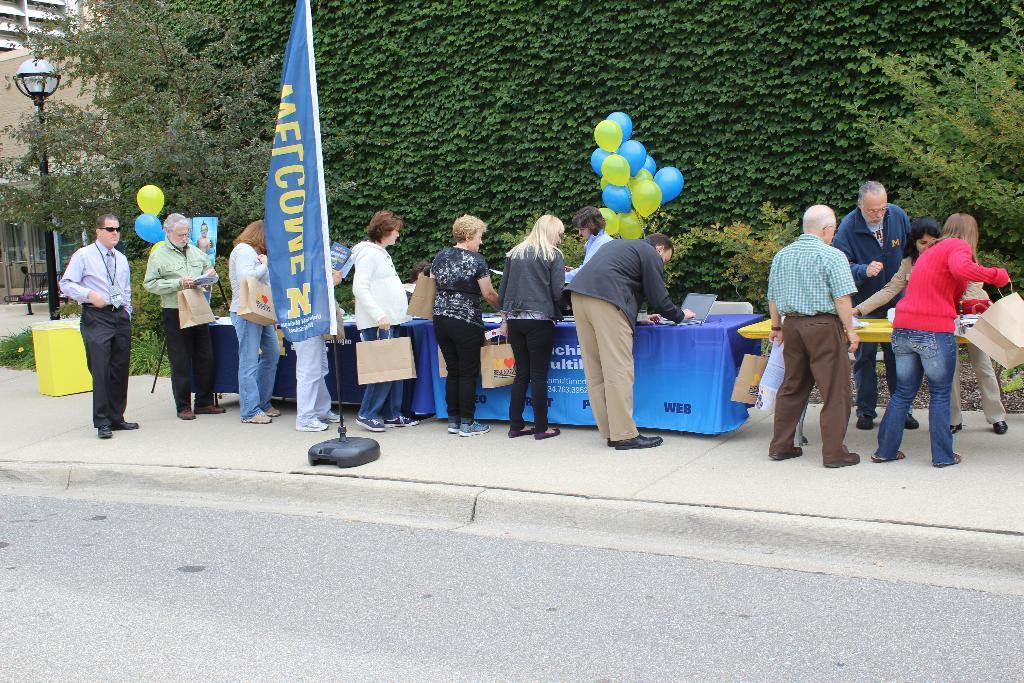How would you summarize this image in a sentence or two? This is an outside view. At the bottom there is a road. In the background there are few people standing facing towards the back side. In front of these people there is a table which is covered with a cloth. On the table there are some objects. The people are holding the bags in their hands and also there is a flag is placed on the footpath. In background there are some plants and balloons. On the left side there is a light pole and a building. 